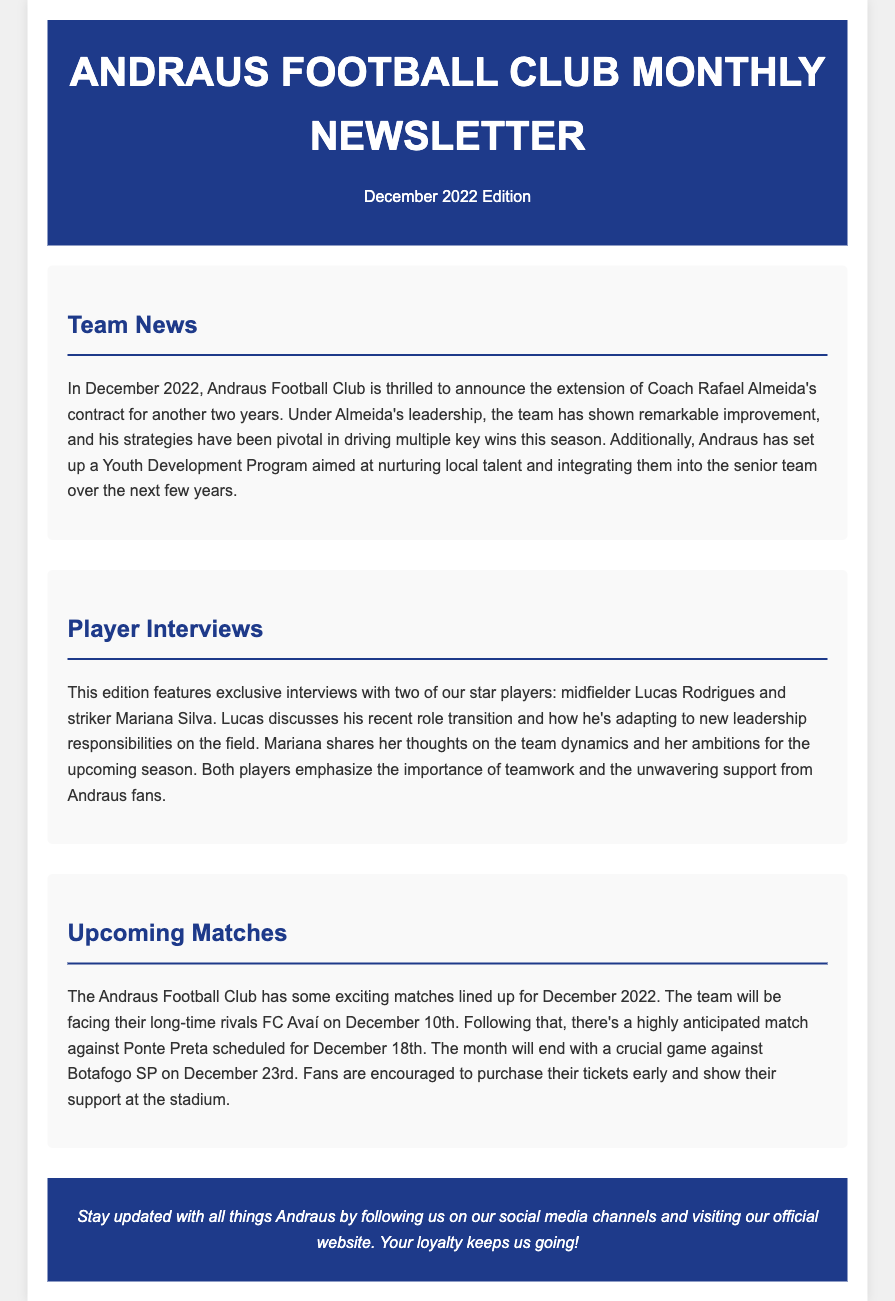What is the title of the newsletter? The title of the newsletter is mentioned in the header section of the document.
Answer: Andraus Football Club Monthly Newsletter Who is the coach whose contract was extended? The document states the name of the coach whose contract was extended.
Answer: Rafael Almeida What is the date of the match against FC Avaí? The date of the match against FC Avaí is listed under the Upcoming Matches section.
Answer: December 10th Which two players are featured in the player interviews? The document identifies key players featured in the interviews section.
Answer: Lucas Rodrigues and Mariana Silva What new program has Andraus Football Club set up? The document mentions a specific new initiative related to player development.
Answer: Youth Development Program What is emphasized by both interviewed players? This is found in the player interviews section, highlighting a core value important to the team.
Answer: Teamwork What is the date of the match against Botafogo SP? The date of another important match is found in the Upcoming Matches section.
Answer: December 23rd What color is the background of the header? The specific color of the header background can be inferred from its description in the document.
Answer: Dark blue 